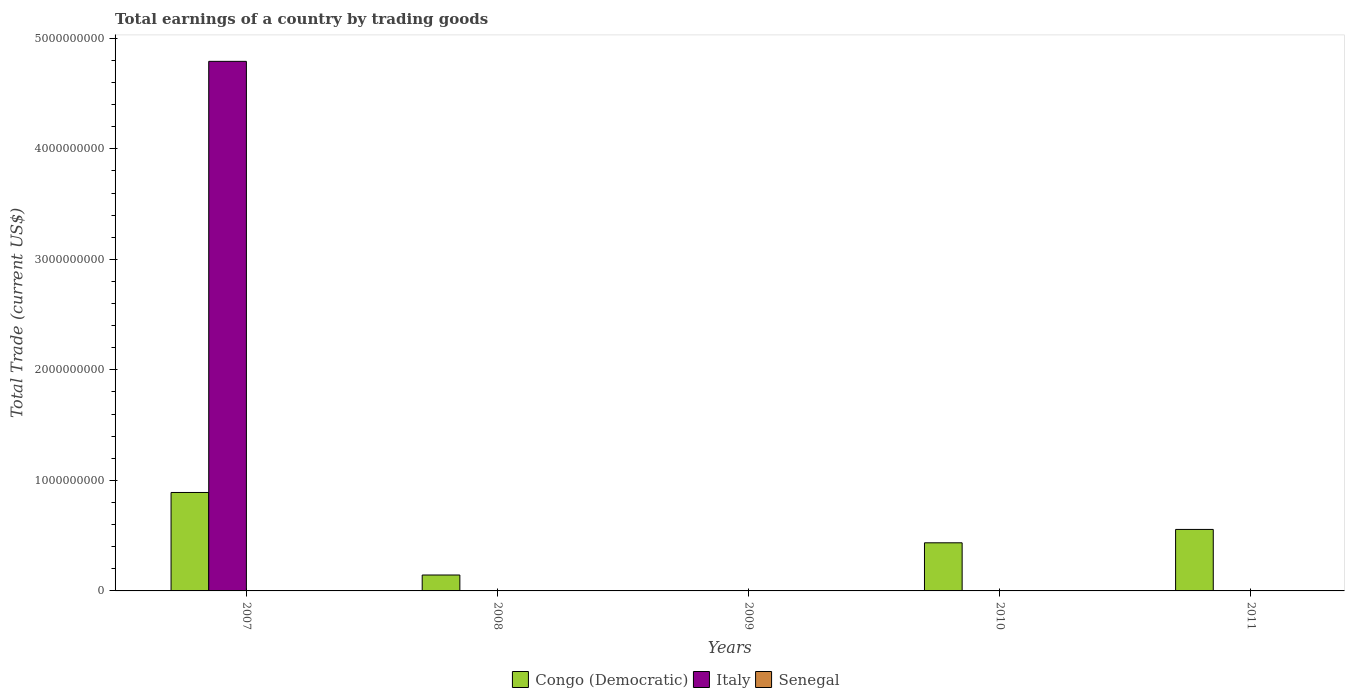How many different coloured bars are there?
Your answer should be very brief. 2. In how many cases, is the number of bars for a given year not equal to the number of legend labels?
Offer a very short reply. 5. Across all years, what is the maximum total earnings in Italy?
Offer a very short reply. 4.79e+09. In which year was the total earnings in Italy maximum?
Keep it short and to the point. 2007. What is the total total earnings in Italy in the graph?
Your response must be concise. 4.79e+09. What is the difference between the total earnings in Congo (Democratic) in 2008 and that in 2011?
Your answer should be compact. -4.12e+08. What is the difference between the total earnings in Congo (Democratic) in 2008 and the total earnings in Senegal in 2009?
Your response must be concise. 1.44e+08. What is the average total earnings in Congo (Democratic) per year?
Provide a short and direct response. 4.05e+08. In how many years, is the total earnings in Senegal greater than 1200000000 US$?
Provide a short and direct response. 0. What is the ratio of the total earnings in Congo (Democratic) in 2007 to that in 2008?
Your answer should be very brief. 6.19. What is the difference between the highest and the second highest total earnings in Congo (Democratic)?
Offer a very short reply. 3.34e+08. What is the difference between the highest and the lowest total earnings in Congo (Democratic)?
Give a very brief answer. 8.91e+08. In how many years, is the total earnings in Italy greater than the average total earnings in Italy taken over all years?
Your response must be concise. 1. Is the sum of the total earnings in Congo (Democratic) in 2008 and 2011 greater than the maximum total earnings in Italy across all years?
Provide a short and direct response. No. How many bars are there?
Your answer should be compact. 5. Does the graph contain any zero values?
Provide a succinct answer. Yes. How are the legend labels stacked?
Ensure brevity in your answer.  Horizontal. What is the title of the graph?
Your answer should be very brief. Total earnings of a country by trading goods. What is the label or title of the Y-axis?
Keep it short and to the point. Total Trade (current US$). What is the Total Trade (current US$) in Congo (Democratic) in 2007?
Your response must be concise. 8.91e+08. What is the Total Trade (current US$) of Italy in 2007?
Offer a terse response. 4.79e+09. What is the Total Trade (current US$) of Congo (Democratic) in 2008?
Keep it short and to the point. 1.44e+08. What is the Total Trade (current US$) of Congo (Democratic) in 2009?
Offer a very short reply. 0. What is the Total Trade (current US$) of Italy in 2009?
Offer a very short reply. 0. What is the Total Trade (current US$) in Senegal in 2009?
Your answer should be very brief. 0. What is the Total Trade (current US$) of Congo (Democratic) in 2010?
Ensure brevity in your answer.  4.35e+08. What is the Total Trade (current US$) of Italy in 2010?
Your answer should be very brief. 0. What is the Total Trade (current US$) in Senegal in 2010?
Offer a terse response. 0. What is the Total Trade (current US$) in Congo (Democratic) in 2011?
Your response must be concise. 5.56e+08. What is the Total Trade (current US$) of Senegal in 2011?
Your answer should be very brief. 0. Across all years, what is the maximum Total Trade (current US$) of Congo (Democratic)?
Offer a very short reply. 8.91e+08. Across all years, what is the maximum Total Trade (current US$) of Italy?
Your response must be concise. 4.79e+09. Across all years, what is the minimum Total Trade (current US$) in Congo (Democratic)?
Provide a succinct answer. 0. Across all years, what is the minimum Total Trade (current US$) of Italy?
Your response must be concise. 0. What is the total Total Trade (current US$) of Congo (Democratic) in the graph?
Make the answer very short. 2.03e+09. What is the total Total Trade (current US$) in Italy in the graph?
Offer a very short reply. 4.79e+09. What is the difference between the Total Trade (current US$) of Congo (Democratic) in 2007 and that in 2008?
Keep it short and to the point. 7.47e+08. What is the difference between the Total Trade (current US$) in Congo (Democratic) in 2007 and that in 2010?
Your answer should be compact. 4.55e+08. What is the difference between the Total Trade (current US$) in Congo (Democratic) in 2007 and that in 2011?
Offer a terse response. 3.34e+08. What is the difference between the Total Trade (current US$) of Congo (Democratic) in 2008 and that in 2010?
Provide a succinct answer. -2.91e+08. What is the difference between the Total Trade (current US$) in Congo (Democratic) in 2008 and that in 2011?
Provide a succinct answer. -4.12e+08. What is the difference between the Total Trade (current US$) in Congo (Democratic) in 2010 and that in 2011?
Your response must be concise. -1.21e+08. What is the average Total Trade (current US$) in Congo (Democratic) per year?
Give a very brief answer. 4.05e+08. What is the average Total Trade (current US$) in Italy per year?
Offer a terse response. 9.58e+08. What is the average Total Trade (current US$) of Senegal per year?
Give a very brief answer. 0. In the year 2007, what is the difference between the Total Trade (current US$) of Congo (Democratic) and Total Trade (current US$) of Italy?
Your response must be concise. -3.90e+09. What is the ratio of the Total Trade (current US$) of Congo (Democratic) in 2007 to that in 2008?
Ensure brevity in your answer.  6.19. What is the ratio of the Total Trade (current US$) in Congo (Democratic) in 2007 to that in 2010?
Your answer should be very brief. 2.05. What is the ratio of the Total Trade (current US$) of Congo (Democratic) in 2007 to that in 2011?
Provide a succinct answer. 1.6. What is the ratio of the Total Trade (current US$) in Congo (Democratic) in 2008 to that in 2010?
Give a very brief answer. 0.33. What is the ratio of the Total Trade (current US$) of Congo (Democratic) in 2008 to that in 2011?
Your answer should be compact. 0.26. What is the ratio of the Total Trade (current US$) in Congo (Democratic) in 2010 to that in 2011?
Provide a succinct answer. 0.78. What is the difference between the highest and the second highest Total Trade (current US$) of Congo (Democratic)?
Provide a succinct answer. 3.34e+08. What is the difference between the highest and the lowest Total Trade (current US$) in Congo (Democratic)?
Keep it short and to the point. 8.91e+08. What is the difference between the highest and the lowest Total Trade (current US$) in Italy?
Provide a succinct answer. 4.79e+09. 